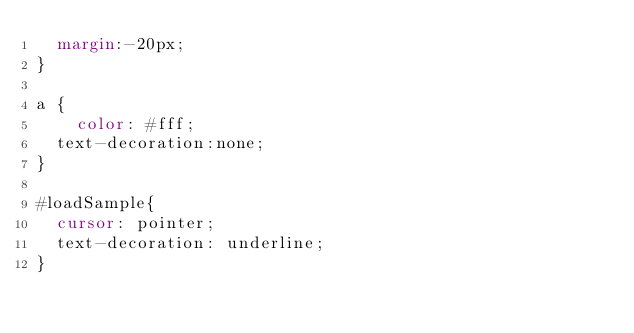Convert code to text. <code><loc_0><loc_0><loc_500><loc_500><_CSS_>	margin:-20px;
}

a {
    color: #fff;
	text-decoration:none;
}

#loadSample{
	cursor: pointer;
	text-decoration: underline;
}</code> 